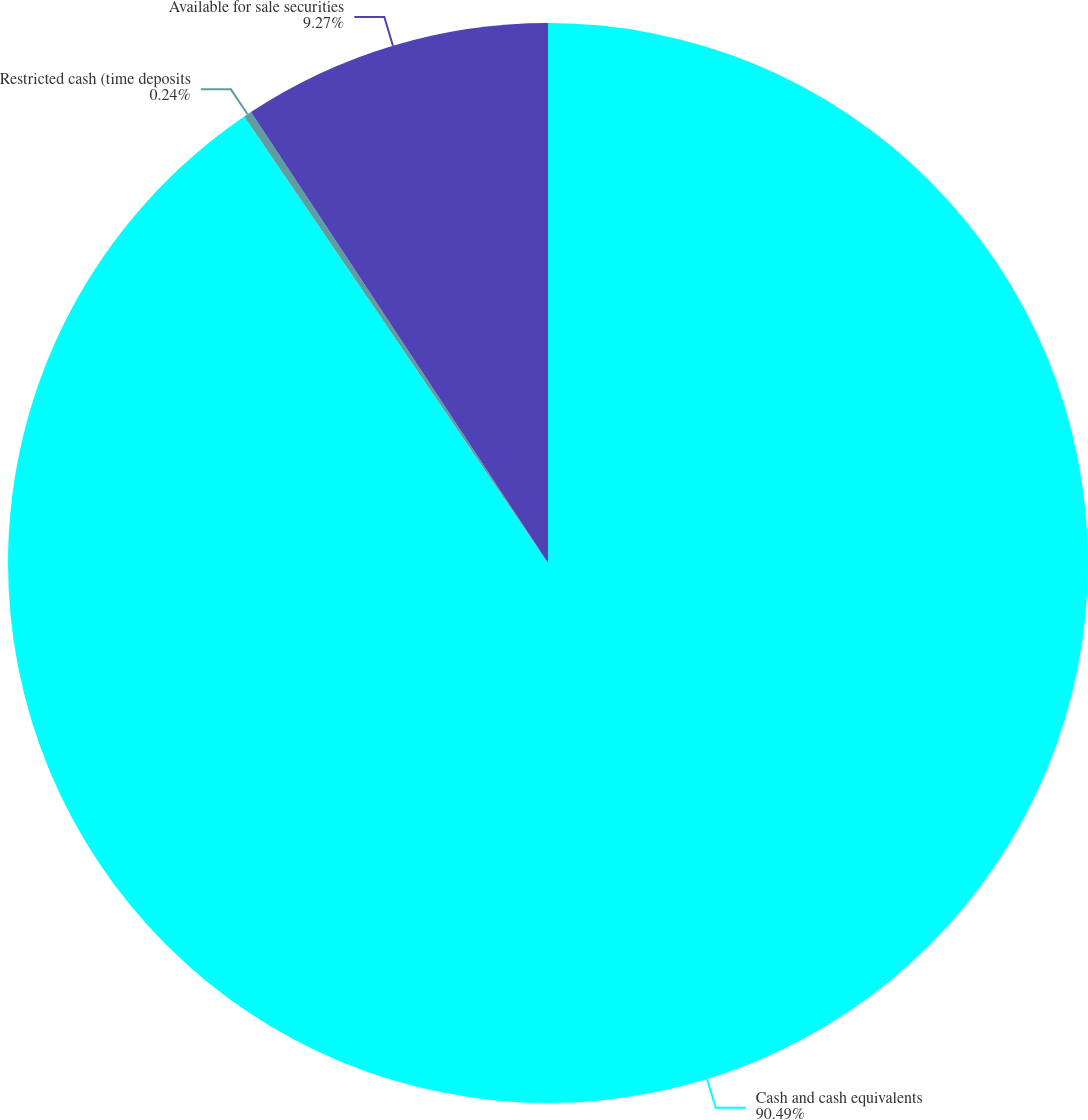Convert chart. <chart><loc_0><loc_0><loc_500><loc_500><pie_chart><fcel>Cash and cash equivalents<fcel>Restricted cash (time deposits<fcel>Available for sale securities<nl><fcel>90.49%<fcel>0.24%<fcel>9.27%<nl></chart> 